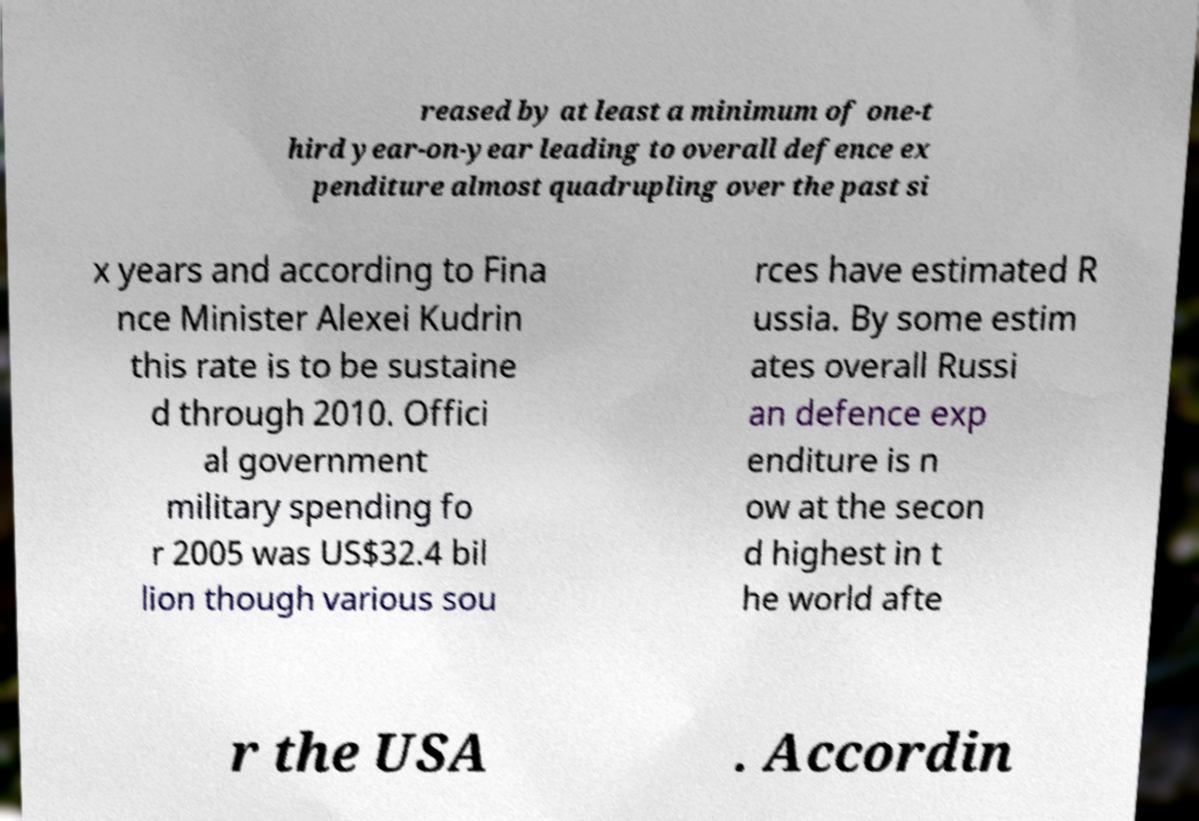There's text embedded in this image that I need extracted. Can you transcribe it verbatim? reased by at least a minimum of one-t hird year-on-year leading to overall defence ex penditure almost quadrupling over the past si x years and according to Fina nce Minister Alexei Kudrin this rate is to be sustaine d through 2010. Offici al government military spending fo r 2005 was US$32.4 bil lion though various sou rces have estimated R ussia. By some estim ates overall Russi an defence exp enditure is n ow at the secon d highest in t he world afte r the USA . Accordin 